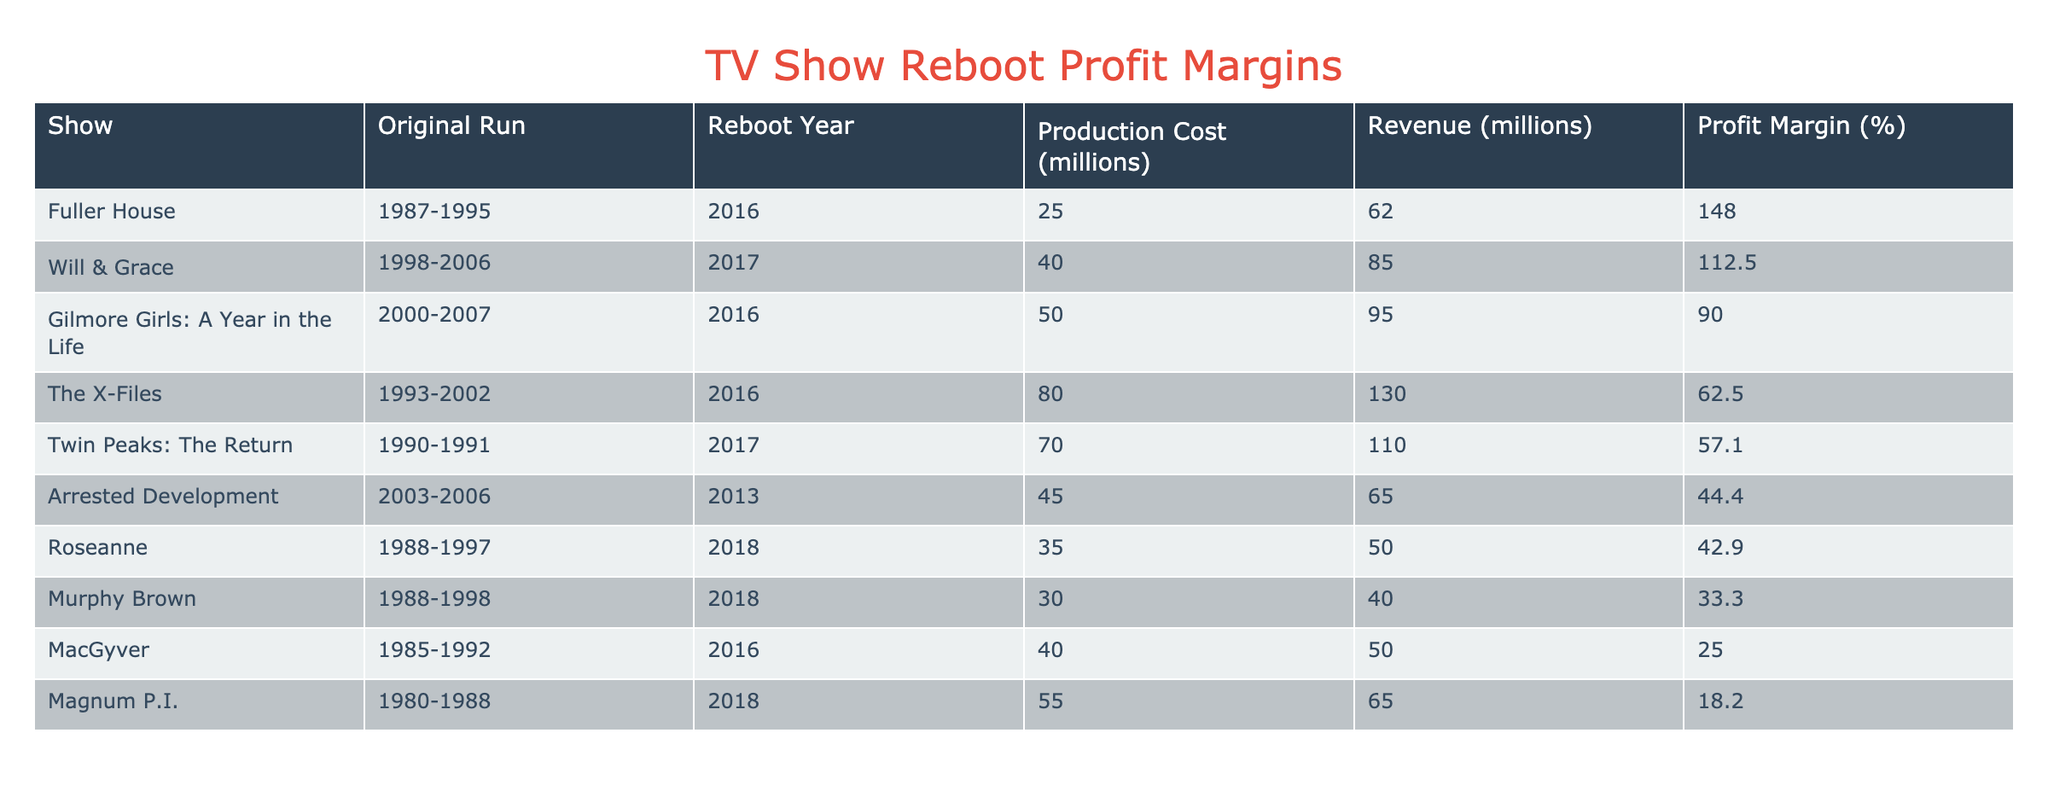What is the profit margin of Fuller House? To find the profit margin of Fuller House, locate the row for Fuller House in the table. The profit margin listed in that row is 148%.
Answer: 148% Which reboot had the highest production cost? By reviewing the production costs column, the highest amount listed is 80 million, associated with The X-Files.
Answer: The X-Files What is the average profit margin of the reboots listed? To find the average profit margin, sum all the profit margins: 148 + 112.5 + 90 + 62.5 + 57.1 + 44.4 + 42.9 + 33.3 + 25 + 18.2 = 532.9. There are 10 reboots, so the average is 532.9 / 10 = 53.29.
Answer: 53.29 Did any reboot release after 2017 have a profit margin greater than 50%? The reboots after 2017 are Roseanne and Murphy Brown. Roseanne has a profit margin of 42.9%, and Murphy Brown has 33.3%. Neither exceeds 50%.
Answer: No What is the difference in profit margin between Will & Grace and Murhpy Brown? The profit margin of Will & Grace is 112.5%, while Murphy Brown’s profit margin is 33.3%. The difference is calculated as 112.5 - 33.3 = 79.2%.
Answer: 79.2% Which show has the lowest profit margin, and what is it? Looking through the profit margins, the lowest value is 18.2% linked to Magnum P.I. Therefore, Magnum P.I. has the lowest profit margin.
Answer: Magnum P.I., 18.2% How many shows have a profit margin greater than 60%? Examine the profit margin column for values greater than 60%. The shows with profit margins of 148%, 112.5%, and 90% qualify, making a total of 3 shows.
Answer: 3 Is the production cost of Gilmore Girls: A Year in the Life lower than the revenue? The production cost for Gilmore Girls: A Year in the Life is 50 million, and the revenue is 95 million. Since 50 million is less than 95 million, the statement is true.
Answer: Yes 